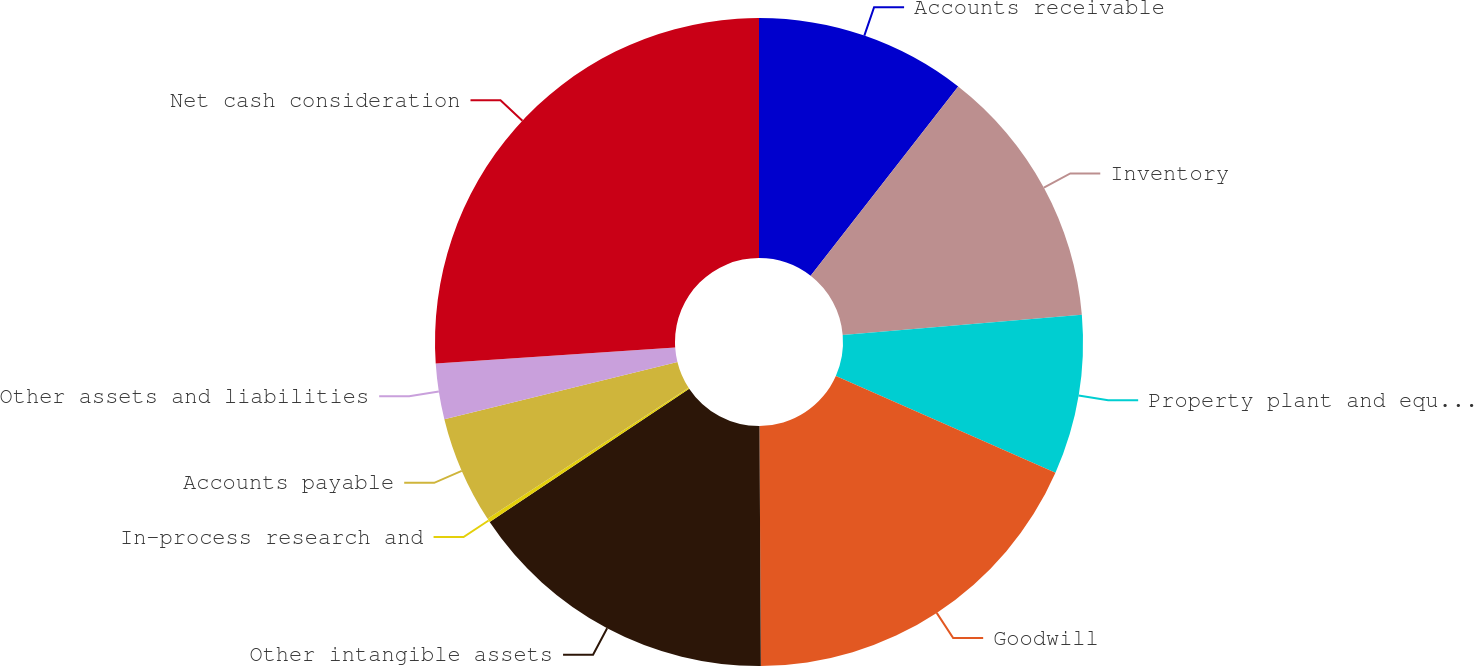Convert chart. <chart><loc_0><loc_0><loc_500><loc_500><pie_chart><fcel>Accounts receivable<fcel>Inventory<fcel>Property plant and equipment<fcel>Goodwill<fcel>Other intangible assets<fcel>In-process research and<fcel>Accounts payable<fcel>Other assets and liabilities<fcel>Net cash consideration<nl><fcel>10.54%<fcel>13.12%<fcel>7.95%<fcel>18.3%<fcel>15.71%<fcel>0.19%<fcel>5.36%<fcel>2.77%<fcel>26.06%<nl></chart> 